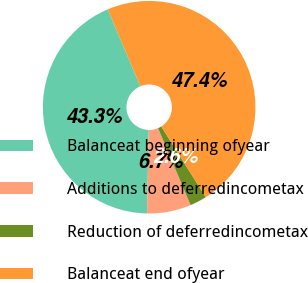<chart> <loc_0><loc_0><loc_500><loc_500><pie_chart><fcel>Balanceat beginning ofyear<fcel>Additions to deferredincometax<fcel>Reduction of deferredincometax<fcel>Balanceat end ofyear<nl><fcel>43.31%<fcel>6.69%<fcel>2.57%<fcel>47.43%<nl></chart> 